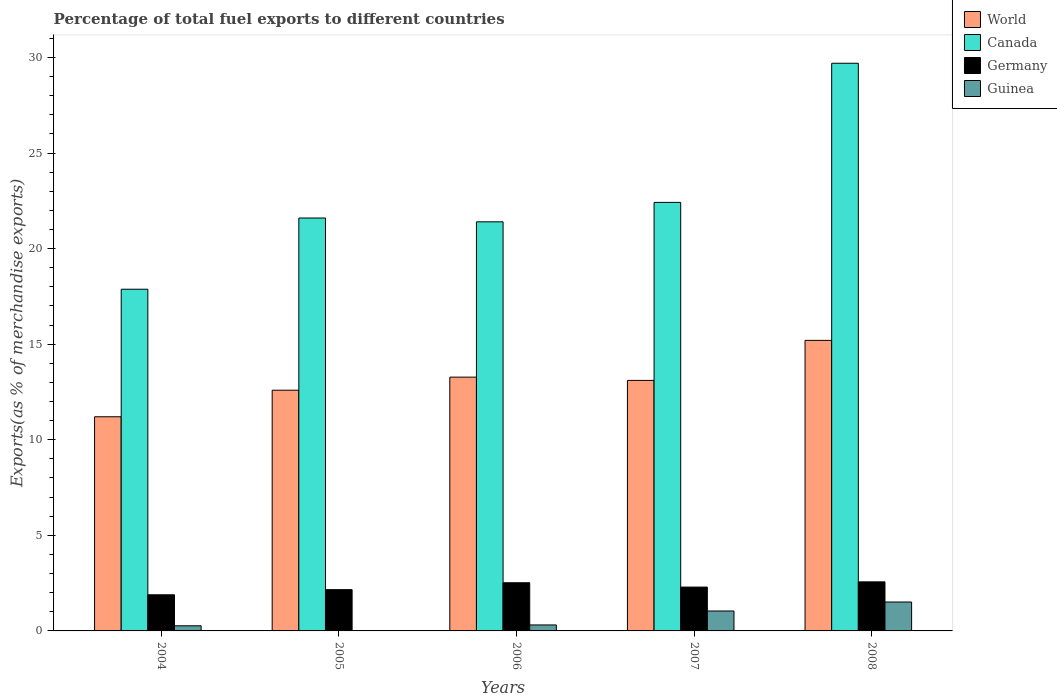How many different coloured bars are there?
Ensure brevity in your answer.  4. How many groups of bars are there?
Your answer should be very brief. 5. Are the number of bars per tick equal to the number of legend labels?
Keep it short and to the point. Yes. Are the number of bars on each tick of the X-axis equal?
Your answer should be compact. Yes. How many bars are there on the 2nd tick from the left?
Provide a short and direct response. 4. How many bars are there on the 5th tick from the right?
Your answer should be compact. 4. What is the percentage of exports to different countries in World in 2008?
Ensure brevity in your answer.  15.2. Across all years, what is the maximum percentage of exports to different countries in Germany?
Offer a very short reply. 2.57. Across all years, what is the minimum percentage of exports to different countries in Germany?
Ensure brevity in your answer.  1.89. In which year was the percentage of exports to different countries in World maximum?
Offer a very short reply. 2008. What is the total percentage of exports to different countries in World in the graph?
Your response must be concise. 65.38. What is the difference between the percentage of exports to different countries in Canada in 2005 and that in 2007?
Offer a terse response. -0.82. What is the difference between the percentage of exports to different countries in Germany in 2008 and the percentage of exports to different countries in Canada in 2007?
Your answer should be compact. -19.85. What is the average percentage of exports to different countries in Germany per year?
Your answer should be very brief. 2.29. In the year 2008, what is the difference between the percentage of exports to different countries in Canada and percentage of exports to different countries in World?
Provide a short and direct response. 14.5. In how many years, is the percentage of exports to different countries in Canada greater than 5 %?
Offer a very short reply. 5. What is the ratio of the percentage of exports to different countries in Guinea in 2004 to that in 2007?
Provide a succinct answer. 0.26. What is the difference between the highest and the second highest percentage of exports to different countries in Germany?
Your answer should be very brief. 0.05. What is the difference between the highest and the lowest percentage of exports to different countries in Germany?
Your response must be concise. 0.68. Is the sum of the percentage of exports to different countries in World in 2004 and 2008 greater than the maximum percentage of exports to different countries in Canada across all years?
Make the answer very short. No. Is it the case that in every year, the sum of the percentage of exports to different countries in Canada and percentage of exports to different countries in Guinea is greater than the sum of percentage of exports to different countries in World and percentage of exports to different countries in Germany?
Offer a terse response. No. How many bars are there?
Ensure brevity in your answer.  20. How many years are there in the graph?
Offer a terse response. 5. What is the difference between two consecutive major ticks on the Y-axis?
Your answer should be very brief. 5. Are the values on the major ticks of Y-axis written in scientific E-notation?
Make the answer very short. No. Does the graph contain any zero values?
Keep it short and to the point. No. Does the graph contain grids?
Provide a short and direct response. No. How many legend labels are there?
Ensure brevity in your answer.  4. How are the legend labels stacked?
Your answer should be very brief. Vertical. What is the title of the graph?
Offer a very short reply. Percentage of total fuel exports to different countries. Does "Sint Maarten (Dutch part)" appear as one of the legend labels in the graph?
Your answer should be compact. No. What is the label or title of the Y-axis?
Offer a terse response. Exports(as % of merchandise exports). What is the Exports(as % of merchandise exports) of World in 2004?
Provide a short and direct response. 11.2. What is the Exports(as % of merchandise exports) in Canada in 2004?
Your response must be concise. 17.87. What is the Exports(as % of merchandise exports) of Germany in 2004?
Provide a short and direct response. 1.89. What is the Exports(as % of merchandise exports) of Guinea in 2004?
Your answer should be very brief. 0.27. What is the Exports(as % of merchandise exports) of World in 2005?
Your answer should be very brief. 12.59. What is the Exports(as % of merchandise exports) of Canada in 2005?
Your answer should be compact. 21.6. What is the Exports(as % of merchandise exports) in Germany in 2005?
Offer a very short reply. 2.16. What is the Exports(as % of merchandise exports) of Guinea in 2005?
Give a very brief answer. 3.9069582544466e-5. What is the Exports(as % of merchandise exports) in World in 2006?
Make the answer very short. 13.28. What is the Exports(as % of merchandise exports) of Canada in 2006?
Make the answer very short. 21.4. What is the Exports(as % of merchandise exports) in Germany in 2006?
Keep it short and to the point. 2.52. What is the Exports(as % of merchandise exports) of Guinea in 2006?
Your response must be concise. 0.31. What is the Exports(as % of merchandise exports) in World in 2007?
Keep it short and to the point. 13.11. What is the Exports(as % of merchandise exports) of Canada in 2007?
Keep it short and to the point. 22.42. What is the Exports(as % of merchandise exports) of Germany in 2007?
Provide a succinct answer. 2.29. What is the Exports(as % of merchandise exports) in Guinea in 2007?
Keep it short and to the point. 1.04. What is the Exports(as % of merchandise exports) of World in 2008?
Your answer should be very brief. 15.2. What is the Exports(as % of merchandise exports) in Canada in 2008?
Your answer should be compact. 29.7. What is the Exports(as % of merchandise exports) in Germany in 2008?
Your answer should be very brief. 2.57. What is the Exports(as % of merchandise exports) of Guinea in 2008?
Your answer should be very brief. 1.51. Across all years, what is the maximum Exports(as % of merchandise exports) in World?
Your response must be concise. 15.2. Across all years, what is the maximum Exports(as % of merchandise exports) of Canada?
Offer a very short reply. 29.7. Across all years, what is the maximum Exports(as % of merchandise exports) of Germany?
Provide a succinct answer. 2.57. Across all years, what is the maximum Exports(as % of merchandise exports) in Guinea?
Give a very brief answer. 1.51. Across all years, what is the minimum Exports(as % of merchandise exports) of World?
Give a very brief answer. 11.2. Across all years, what is the minimum Exports(as % of merchandise exports) in Canada?
Provide a short and direct response. 17.87. Across all years, what is the minimum Exports(as % of merchandise exports) of Germany?
Offer a terse response. 1.89. Across all years, what is the minimum Exports(as % of merchandise exports) in Guinea?
Ensure brevity in your answer.  3.9069582544466e-5. What is the total Exports(as % of merchandise exports) in World in the graph?
Ensure brevity in your answer.  65.38. What is the total Exports(as % of merchandise exports) in Canada in the graph?
Keep it short and to the point. 112.99. What is the total Exports(as % of merchandise exports) of Germany in the graph?
Make the answer very short. 11.43. What is the total Exports(as % of merchandise exports) in Guinea in the graph?
Give a very brief answer. 3.14. What is the difference between the Exports(as % of merchandise exports) of World in 2004 and that in 2005?
Ensure brevity in your answer.  -1.39. What is the difference between the Exports(as % of merchandise exports) in Canada in 2004 and that in 2005?
Ensure brevity in your answer.  -3.73. What is the difference between the Exports(as % of merchandise exports) of Germany in 2004 and that in 2005?
Your response must be concise. -0.27. What is the difference between the Exports(as % of merchandise exports) in Guinea in 2004 and that in 2005?
Ensure brevity in your answer.  0.27. What is the difference between the Exports(as % of merchandise exports) in World in 2004 and that in 2006?
Keep it short and to the point. -2.07. What is the difference between the Exports(as % of merchandise exports) in Canada in 2004 and that in 2006?
Give a very brief answer. -3.53. What is the difference between the Exports(as % of merchandise exports) in Germany in 2004 and that in 2006?
Provide a succinct answer. -0.63. What is the difference between the Exports(as % of merchandise exports) of Guinea in 2004 and that in 2006?
Your response must be concise. -0.04. What is the difference between the Exports(as % of merchandise exports) in World in 2004 and that in 2007?
Offer a very short reply. -1.9. What is the difference between the Exports(as % of merchandise exports) of Canada in 2004 and that in 2007?
Make the answer very short. -4.54. What is the difference between the Exports(as % of merchandise exports) of Germany in 2004 and that in 2007?
Make the answer very short. -0.4. What is the difference between the Exports(as % of merchandise exports) in Guinea in 2004 and that in 2007?
Your answer should be very brief. -0.77. What is the difference between the Exports(as % of merchandise exports) in World in 2004 and that in 2008?
Offer a very short reply. -4. What is the difference between the Exports(as % of merchandise exports) of Canada in 2004 and that in 2008?
Give a very brief answer. -11.82. What is the difference between the Exports(as % of merchandise exports) in Germany in 2004 and that in 2008?
Provide a succinct answer. -0.68. What is the difference between the Exports(as % of merchandise exports) of Guinea in 2004 and that in 2008?
Your response must be concise. -1.24. What is the difference between the Exports(as % of merchandise exports) in World in 2005 and that in 2006?
Your answer should be very brief. -0.68. What is the difference between the Exports(as % of merchandise exports) of Canada in 2005 and that in 2006?
Keep it short and to the point. 0.2. What is the difference between the Exports(as % of merchandise exports) in Germany in 2005 and that in 2006?
Ensure brevity in your answer.  -0.36. What is the difference between the Exports(as % of merchandise exports) of Guinea in 2005 and that in 2006?
Keep it short and to the point. -0.31. What is the difference between the Exports(as % of merchandise exports) of World in 2005 and that in 2007?
Your answer should be very brief. -0.51. What is the difference between the Exports(as % of merchandise exports) in Canada in 2005 and that in 2007?
Provide a short and direct response. -0.82. What is the difference between the Exports(as % of merchandise exports) in Germany in 2005 and that in 2007?
Your answer should be compact. -0.13. What is the difference between the Exports(as % of merchandise exports) of Guinea in 2005 and that in 2007?
Give a very brief answer. -1.04. What is the difference between the Exports(as % of merchandise exports) of World in 2005 and that in 2008?
Provide a short and direct response. -2.61. What is the difference between the Exports(as % of merchandise exports) of Canada in 2005 and that in 2008?
Give a very brief answer. -8.1. What is the difference between the Exports(as % of merchandise exports) of Germany in 2005 and that in 2008?
Provide a short and direct response. -0.41. What is the difference between the Exports(as % of merchandise exports) of Guinea in 2005 and that in 2008?
Your answer should be compact. -1.51. What is the difference between the Exports(as % of merchandise exports) in World in 2006 and that in 2007?
Your response must be concise. 0.17. What is the difference between the Exports(as % of merchandise exports) of Canada in 2006 and that in 2007?
Your answer should be compact. -1.02. What is the difference between the Exports(as % of merchandise exports) of Germany in 2006 and that in 2007?
Offer a terse response. 0.23. What is the difference between the Exports(as % of merchandise exports) of Guinea in 2006 and that in 2007?
Your answer should be compact. -0.73. What is the difference between the Exports(as % of merchandise exports) of World in 2006 and that in 2008?
Your answer should be compact. -1.92. What is the difference between the Exports(as % of merchandise exports) of Canada in 2006 and that in 2008?
Make the answer very short. -8.29. What is the difference between the Exports(as % of merchandise exports) of Germany in 2006 and that in 2008?
Offer a very short reply. -0.05. What is the difference between the Exports(as % of merchandise exports) in Guinea in 2006 and that in 2008?
Provide a succinct answer. -1.2. What is the difference between the Exports(as % of merchandise exports) in World in 2007 and that in 2008?
Your answer should be very brief. -2.09. What is the difference between the Exports(as % of merchandise exports) in Canada in 2007 and that in 2008?
Your answer should be very brief. -7.28. What is the difference between the Exports(as % of merchandise exports) of Germany in 2007 and that in 2008?
Give a very brief answer. -0.27. What is the difference between the Exports(as % of merchandise exports) of Guinea in 2007 and that in 2008?
Your response must be concise. -0.47. What is the difference between the Exports(as % of merchandise exports) of World in 2004 and the Exports(as % of merchandise exports) of Canada in 2005?
Your answer should be compact. -10.4. What is the difference between the Exports(as % of merchandise exports) of World in 2004 and the Exports(as % of merchandise exports) of Germany in 2005?
Provide a short and direct response. 9.04. What is the difference between the Exports(as % of merchandise exports) of World in 2004 and the Exports(as % of merchandise exports) of Guinea in 2005?
Provide a succinct answer. 11.2. What is the difference between the Exports(as % of merchandise exports) in Canada in 2004 and the Exports(as % of merchandise exports) in Germany in 2005?
Ensure brevity in your answer.  15.72. What is the difference between the Exports(as % of merchandise exports) of Canada in 2004 and the Exports(as % of merchandise exports) of Guinea in 2005?
Provide a short and direct response. 17.87. What is the difference between the Exports(as % of merchandise exports) in Germany in 2004 and the Exports(as % of merchandise exports) in Guinea in 2005?
Your response must be concise. 1.89. What is the difference between the Exports(as % of merchandise exports) of World in 2004 and the Exports(as % of merchandise exports) of Canada in 2006?
Your answer should be compact. -10.2. What is the difference between the Exports(as % of merchandise exports) of World in 2004 and the Exports(as % of merchandise exports) of Germany in 2006?
Provide a short and direct response. 8.68. What is the difference between the Exports(as % of merchandise exports) in World in 2004 and the Exports(as % of merchandise exports) in Guinea in 2006?
Your answer should be very brief. 10.89. What is the difference between the Exports(as % of merchandise exports) in Canada in 2004 and the Exports(as % of merchandise exports) in Germany in 2006?
Provide a short and direct response. 15.36. What is the difference between the Exports(as % of merchandise exports) in Canada in 2004 and the Exports(as % of merchandise exports) in Guinea in 2006?
Keep it short and to the point. 17.56. What is the difference between the Exports(as % of merchandise exports) of Germany in 2004 and the Exports(as % of merchandise exports) of Guinea in 2006?
Your response must be concise. 1.58. What is the difference between the Exports(as % of merchandise exports) of World in 2004 and the Exports(as % of merchandise exports) of Canada in 2007?
Your answer should be very brief. -11.21. What is the difference between the Exports(as % of merchandise exports) of World in 2004 and the Exports(as % of merchandise exports) of Germany in 2007?
Give a very brief answer. 8.91. What is the difference between the Exports(as % of merchandise exports) in World in 2004 and the Exports(as % of merchandise exports) in Guinea in 2007?
Offer a very short reply. 10.16. What is the difference between the Exports(as % of merchandise exports) in Canada in 2004 and the Exports(as % of merchandise exports) in Germany in 2007?
Ensure brevity in your answer.  15.58. What is the difference between the Exports(as % of merchandise exports) of Canada in 2004 and the Exports(as % of merchandise exports) of Guinea in 2007?
Offer a very short reply. 16.83. What is the difference between the Exports(as % of merchandise exports) of Germany in 2004 and the Exports(as % of merchandise exports) of Guinea in 2007?
Provide a succinct answer. 0.85. What is the difference between the Exports(as % of merchandise exports) in World in 2004 and the Exports(as % of merchandise exports) in Canada in 2008?
Offer a very short reply. -18.49. What is the difference between the Exports(as % of merchandise exports) in World in 2004 and the Exports(as % of merchandise exports) in Germany in 2008?
Give a very brief answer. 8.64. What is the difference between the Exports(as % of merchandise exports) of World in 2004 and the Exports(as % of merchandise exports) of Guinea in 2008?
Offer a very short reply. 9.69. What is the difference between the Exports(as % of merchandise exports) in Canada in 2004 and the Exports(as % of merchandise exports) in Germany in 2008?
Offer a terse response. 15.31. What is the difference between the Exports(as % of merchandise exports) in Canada in 2004 and the Exports(as % of merchandise exports) in Guinea in 2008?
Make the answer very short. 16.36. What is the difference between the Exports(as % of merchandise exports) in Germany in 2004 and the Exports(as % of merchandise exports) in Guinea in 2008?
Your response must be concise. 0.38. What is the difference between the Exports(as % of merchandise exports) of World in 2005 and the Exports(as % of merchandise exports) of Canada in 2006?
Your answer should be very brief. -8.81. What is the difference between the Exports(as % of merchandise exports) in World in 2005 and the Exports(as % of merchandise exports) in Germany in 2006?
Keep it short and to the point. 10.07. What is the difference between the Exports(as % of merchandise exports) of World in 2005 and the Exports(as % of merchandise exports) of Guinea in 2006?
Provide a short and direct response. 12.28. What is the difference between the Exports(as % of merchandise exports) in Canada in 2005 and the Exports(as % of merchandise exports) in Germany in 2006?
Your answer should be very brief. 19.08. What is the difference between the Exports(as % of merchandise exports) in Canada in 2005 and the Exports(as % of merchandise exports) in Guinea in 2006?
Provide a succinct answer. 21.29. What is the difference between the Exports(as % of merchandise exports) in Germany in 2005 and the Exports(as % of merchandise exports) in Guinea in 2006?
Keep it short and to the point. 1.85. What is the difference between the Exports(as % of merchandise exports) in World in 2005 and the Exports(as % of merchandise exports) in Canada in 2007?
Offer a terse response. -9.83. What is the difference between the Exports(as % of merchandise exports) of World in 2005 and the Exports(as % of merchandise exports) of Germany in 2007?
Your answer should be very brief. 10.3. What is the difference between the Exports(as % of merchandise exports) in World in 2005 and the Exports(as % of merchandise exports) in Guinea in 2007?
Give a very brief answer. 11.55. What is the difference between the Exports(as % of merchandise exports) of Canada in 2005 and the Exports(as % of merchandise exports) of Germany in 2007?
Your answer should be very brief. 19.31. What is the difference between the Exports(as % of merchandise exports) of Canada in 2005 and the Exports(as % of merchandise exports) of Guinea in 2007?
Your answer should be compact. 20.56. What is the difference between the Exports(as % of merchandise exports) of Germany in 2005 and the Exports(as % of merchandise exports) of Guinea in 2007?
Offer a terse response. 1.12. What is the difference between the Exports(as % of merchandise exports) of World in 2005 and the Exports(as % of merchandise exports) of Canada in 2008?
Make the answer very short. -17.1. What is the difference between the Exports(as % of merchandise exports) of World in 2005 and the Exports(as % of merchandise exports) of Germany in 2008?
Give a very brief answer. 10.03. What is the difference between the Exports(as % of merchandise exports) of World in 2005 and the Exports(as % of merchandise exports) of Guinea in 2008?
Your answer should be very brief. 11.08. What is the difference between the Exports(as % of merchandise exports) in Canada in 2005 and the Exports(as % of merchandise exports) in Germany in 2008?
Give a very brief answer. 19.03. What is the difference between the Exports(as % of merchandise exports) of Canada in 2005 and the Exports(as % of merchandise exports) of Guinea in 2008?
Your response must be concise. 20.09. What is the difference between the Exports(as % of merchandise exports) of Germany in 2005 and the Exports(as % of merchandise exports) of Guinea in 2008?
Provide a short and direct response. 0.65. What is the difference between the Exports(as % of merchandise exports) in World in 2006 and the Exports(as % of merchandise exports) in Canada in 2007?
Keep it short and to the point. -9.14. What is the difference between the Exports(as % of merchandise exports) in World in 2006 and the Exports(as % of merchandise exports) in Germany in 2007?
Make the answer very short. 10.98. What is the difference between the Exports(as % of merchandise exports) in World in 2006 and the Exports(as % of merchandise exports) in Guinea in 2007?
Your answer should be very brief. 12.23. What is the difference between the Exports(as % of merchandise exports) of Canada in 2006 and the Exports(as % of merchandise exports) of Germany in 2007?
Offer a terse response. 19.11. What is the difference between the Exports(as % of merchandise exports) of Canada in 2006 and the Exports(as % of merchandise exports) of Guinea in 2007?
Provide a succinct answer. 20.36. What is the difference between the Exports(as % of merchandise exports) of Germany in 2006 and the Exports(as % of merchandise exports) of Guinea in 2007?
Provide a short and direct response. 1.48. What is the difference between the Exports(as % of merchandise exports) of World in 2006 and the Exports(as % of merchandise exports) of Canada in 2008?
Keep it short and to the point. -16.42. What is the difference between the Exports(as % of merchandise exports) of World in 2006 and the Exports(as % of merchandise exports) of Germany in 2008?
Ensure brevity in your answer.  10.71. What is the difference between the Exports(as % of merchandise exports) of World in 2006 and the Exports(as % of merchandise exports) of Guinea in 2008?
Provide a short and direct response. 11.76. What is the difference between the Exports(as % of merchandise exports) of Canada in 2006 and the Exports(as % of merchandise exports) of Germany in 2008?
Your response must be concise. 18.83. What is the difference between the Exports(as % of merchandise exports) of Canada in 2006 and the Exports(as % of merchandise exports) of Guinea in 2008?
Provide a short and direct response. 19.89. What is the difference between the Exports(as % of merchandise exports) in Germany in 2006 and the Exports(as % of merchandise exports) in Guinea in 2008?
Provide a succinct answer. 1.01. What is the difference between the Exports(as % of merchandise exports) of World in 2007 and the Exports(as % of merchandise exports) of Canada in 2008?
Provide a short and direct response. -16.59. What is the difference between the Exports(as % of merchandise exports) of World in 2007 and the Exports(as % of merchandise exports) of Germany in 2008?
Offer a very short reply. 10.54. What is the difference between the Exports(as % of merchandise exports) in World in 2007 and the Exports(as % of merchandise exports) in Guinea in 2008?
Give a very brief answer. 11.59. What is the difference between the Exports(as % of merchandise exports) in Canada in 2007 and the Exports(as % of merchandise exports) in Germany in 2008?
Offer a terse response. 19.85. What is the difference between the Exports(as % of merchandise exports) in Canada in 2007 and the Exports(as % of merchandise exports) in Guinea in 2008?
Provide a short and direct response. 20.9. What is the difference between the Exports(as % of merchandise exports) in Germany in 2007 and the Exports(as % of merchandise exports) in Guinea in 2008?
Give a very brief answer. 0.78. What is the average Exports(as % of merchandise exports) of World per year?
Offer a terse response. 13.08. What is the average Exports(as % of merchandise exports) in Canada per year?
Make the answer very short. 22.6. What is the average Exports(as % of merchandise exports) of Germany per year?
Give a very brief answer. 2.29. What is the average Exports(as % of merchandise exports) in Guinea per year?
Keep it short and to the point. 0.63. In the year 2004, what is the difference between the Exports(as % of merchandise exports) of World and Exports(as % of merchandise exports) of Canada?
Offer a terse response. -6.67. In the year 2004, what is the difference between the Exports(as % of merchandise exports) in World and Exports(as % of merchandise exports) in Germany?
Your answer should be compact. 9.31. In the year 2004, what is the difference between the Exports(as % of merchandise exports) in World and Exports(as % of merchandise exports) in Guinea?
Provide a short and direct response. 10.93. In the year 2004, what is the difference between the Exports(as % of merchandise exports) of Canada and Exports(as % of merchandise exports) of Germany?
Make the answer very short. 15.98. In the year 2004, what is the difference between the Exports(as % of merchandise exports) in Canada and Exports(as % of merchandise exports) in Guinea?
Keep it short and to the point. 17.61. In the year 2004, what is the difference between the Exports(as % of merchandise exports) of Germany and Exports(as % of merchandise exports) of Guinea?
Give a very brief answer. 1.62. In the year 2005, what is the difference between the Exports(as % of merchandise exports) in World and Exports(as % of merchandise exports) in Canada?
Give a very brief answer. -9.01. In the year 2005, what is the difference between the Exports(as % of merchandise exports) in World and Exports(as % of merchandise exports) in Germany?
Keep it short and to the point. 10.43. In the year 2005, what is the difference between the Exports(as % of merchandise exports) of World and Exports(as % of merchandise exports) of Guinea?
Make the answer very short. 12.59. In the year 2005, what is the difference between the Exports(as % of merchandise exports) of Canada and Exports(as % of merchandise exports) of Germany?
Give a very brief answer. 19.44. In the year 2005, what is the difference between the Exports(as % of merchandise exports) in Canada and Exports(as % of merchandise exports) in Guinea?
Your response must be concise. 21.6. In the year 2005, what is the difference between the Exports(as % of merchandise exports) in Germany and Exports(as % of merchandise exports) in Guinea?
Your answer should be compact. 2.16. In the year 2006, what is the difference between the Exports(as % of merchandise exports) in World and Exports(as % of merchandise exports) in Canada?
Offer a terse response. -8.12. In the year 2006, what is the difference between the Exports(as % of merchandise exports) of World and Exports(as % of merchandise exports) of Germany?
Offer a very short reply. 10.76. In the year 2006, what is the difference between the Exports(as % of merchandise exports) in World and Exports(as % of merchandise exports) in Guinea?
Keep it short and to the point. 12.96. In the year 2006, what is the difference between the Exports(as % of merchandise exports) in Canada and Exports(as % of merchandise exports) in Germany?
Your response must be concise. 18.88. In the year 2006, what is the difference between the Exports(as % of merchandise exports) of Canada and Exports(as % of merchandise exports) of Guinea?
Offer a very short reply. 21.09. In the year 2006, what is the difference between the Exports(as % of merchandise exports) of Germany and Exports(as % of merchandise exports) of Guinea?
Keep it short and to the point. 2.21. In the year 2007, what is the difference between the Exports(as % of merchandise exports) in World and Exports(as % of merchandise exports) in Canada?
Provide a short and direct response. -9.31. In the year 2007, what is the difference between the Exports(as % of merchandise exports) of World and Exports(as % of merchandise exports) of Germany?
Keep it short and to the point. 10.81. In the year 2007, what is the difference between the Exports(as % of merchandise exports) of World and Exports(as % of merchandise exports) of Guinea?
Your response must be concise. 12.06. In the year 2007, what is the difference between the Exports(as % of merchandise exports) in Canada and Exports(as % of merchandise exports) in Germany?
Keep it short and to the point. 20.12. In the year 2007, what is the difference between the Exports(as % of merchandise exports) in Canada and Exports(as % of merchandise exports) in Guinea?
Provide a succinct answer. 21.37. In the year 2007, what is the difference between the Exports(as % of merchandise exports) in Germany and Exports(as % of merchandise exports) in Guinea?
Your answer should be very brief. 1.25. In the year 2008, what is the difference between the Exports(as % of merchandise exports) in World and Exports(as % of merchandise exports) in Canada?
Give a very brief answer. -14.5. In the year 2008, what is the difference between the Exports(as % of merchandise exports) of World and Exports(as % of merchandise exports) of Germany?
Offer a terse response. 12.63. In the year 2008, what is the difference between the Exports(as % of merchandise exports) of World and Exports(as % of merchandise exports) of Guinea?
Give a very brief answer. 13.69. In the year 2008, what is the difference between the Exports(as % of merchandise exports) of Canada and Exports(as % of merchandise exports) of Germany?
Offer a very short reply. 27.13. In the year 2008, what is the difference between the Exports(as % of merchandise exports) of Canada and Exports(as % of merchandise exports) of Guinea?
Make the answer very short. 28.18. In the year 2008, what is the difference between the Exports(as % of merchandise exports) in Germany and Exports(as % of merchandise exports) in Guinea?
Provide a short and direct response. 1.05. What is the ratio of the Exports(as % of merchandise exports) of World in 2004 to that in 2005?
Ensure brevity in your answer.  0.89. What is the ratio of the Exports(as % of merchandise exports) of Canada in 2004 to that in 2005?
Your answer should be very brief. 0.83. What is the ratio of the Exports(as % of merchandise exports) in Germany in 2004 to that in 2005?
Your response must be concise. 0.88. What is the ratio of the Exports(as % of merchandise exports) of Guinea in 2004 to that in 2005?
Ensure brevity in your answer.  6866.83. What is the ratio of the Exports(as % of merchandise exports) of World in 2004 to that in 2006?
Make the answer very short. 0.84. What is the ratio of the Exports(as % of merchandise exports) of Canada in 2004 to that in 2006?
Ensure brevity in your answer.  0.84. What is the ratio of the Exports(as % of merchandise exports) of Germany in 2004 to that in 2006?
Give a very brief answer. 0.75. What is the ratio of the Exports(as % of merchandise exports) in Guinea in 2004 to that in 2006?
Your answer should be compact. 0.86. What is the ratio of the Exports(as % of merchandise exports) in World in 2004 to that in 2007?
Your answer should be very brief. 0.85. What is the ratio of the Exports(as % of merchandise exports) in Canada in 2004 to that in 2007?
Provide a succinct answer. 0.8. What is the ratio of the Exports(as % of merchandise exports) in Germany in 2004 to that in 2007?
Provide a succinct answer. 0.82. What is the ratio of the Exports(as % of merchandise exports) in Guinea in 2004 to that in 2007?
Your answer should be compact. 0.26. What is the ratio of the Exports(as % of merchandise exports) in World in 2004 to that in 2008?
Your response must be concise. 0.74. What is the ratio of the Exports(as % of merchandise exports) of Canada in 2004 to that in 2008?
Make the answer very short. 0.6. What is the ratio of the Exports(as % of merchandise exports) of Germany in 2004 to that in 2008?
Provide a succinct answer. 0.74. What is the ratio of the Exports(as % of merchandise exports) in Guinea in 2004 to that in 2008?
Your response must be concise. 0.18. What is the ratio of the Exports(as % of merchandise exports) in World in 2005 to that in 2006?
Give a very brief answer. 0.95. What is the ratio of the Exports(as % of merchandise exports) of Canada in 2005 to that in 2006?
Make the answer very short. 1.01. What is the ratio of the Exports(as % of merchandise exports) of World in 2005 to that in 2007?
Provide a short and direct response. 0.96. What is the ratio of the Exports(as % of merchandise exports) of Canada in 2005 to that in 2007?
Give a very brief answer. 0.96. What is the ratio of the Exports(as % of merchandise exports) in Germany in 2005 to that in 2007?
Make the answer very short. 0.94. What is the ratio of the Exports(as % of merchandise exports) in Guinea in 2005 to that in 2007?
Your response must be concise. 0. What is the ratio of the Exports(as % of merchandise exports) in World in 2005 to that in 2008?
Offer a very short reply. 0.83. What is the ratio of the Exports(as % of merchandise exports) of Canada in 2005 to that in 2008?
Your answer should be compact. 0.73. What is the ratio of the Exports(as % of merchandise exports) of Germany in 2005 to that in 2008?
Provide a short and direct response. 0.84. What is the ratio of the Exports(as % of merchandise exports) of Guinea in 2005 to that in 2008?
Your answer should be very brief. 0. What is the ratio of the Exports(as % of merchandise exports) in World in 2006 to that in 2007?
Offer a very short reply. 1.01. What is the ratio of the Exports(as % of merchandise exports) in Canada in 2006 to that in 2007?
Provide a succinct answer. 0.95. What is the ratio of the Exports(as % of merchandise exports) of Germany in 2006 to that in 2007?
Offer a very short reply. 1.1. What is the ratio of the Exports(as % of merchandise exports) of Guinea in 2006 to that in 2007?
Keep it short and to the point. 0.3. What is the ratio of the Exports(as % of merchandise exports) in World in 2006 to that in 2008?
Provide a succinct answer. 0.87. What is the ratio of the Exports(as % of merchandise exports) in Canada in 2006 to that in 2008?
Provide a short and direct response. 0.72. What is the ratio of the Exports(as % of merchandise exports) of Germany in 2006 to that in 2008?
Your answer should be compact. 0.98. What is the ratio of the Exports(as % of merchandise exports) of Guinea in 2006 to that in 2008?
Provide a short and direct response. 0.21. What is the ratio of the Exports(as % of merchandise exports) of World in 2007 to that in 2008?
Provide a short and direct response. 0.86. What is the ratio of the Exports(as % of merchandise exports) in Canada in 2007 to that in 2008?
Offer a terse response. 0.75. What is the ratio of the Exports(as % of merchandise exports) in Germany in 2007 to that in 2008?
Give a very brief answer. 0.89. What is the ratio of the Exports(as % of merchandise exports) in Guinea in 2007 to that in 2008?
Make the answer very short. 0.69. What is the difference between the highest and the second highest Exports(as % of merchandise exports) in World?
Give a very brief answer. 1.92. What is the difference between the highest and the second highest Exports(as % of merchandise exports) in Canada?
Make the answer very short. 7.28. What is the difference between the highest and the second highest Exports(as % of merchandise exports) in Germany?
Make the answer very short. 0.05. What is the difference between the highest and the second highest Exports(as % of merchandise exports) in Guinea?
Keep it short and to the point. 0.47. What is the difference between the highest and the lowest Exports(as % of merchandise exports) in World?
Ensure brevity in your answer.  4. What is the difference between the highest and the lowest Exports(as % of merchandise exports) in Canada?
Provide a succinct answer. 11.82. What is the difference between the highest and the lowest Exports(as % of merchandise exports) in Germany?
Provide a short and direct response. 0.68. What is the difference between the highest and the lowest Exports(as % of merchandise exports) in Guinea?
Your answer should be compact. 1.51. 